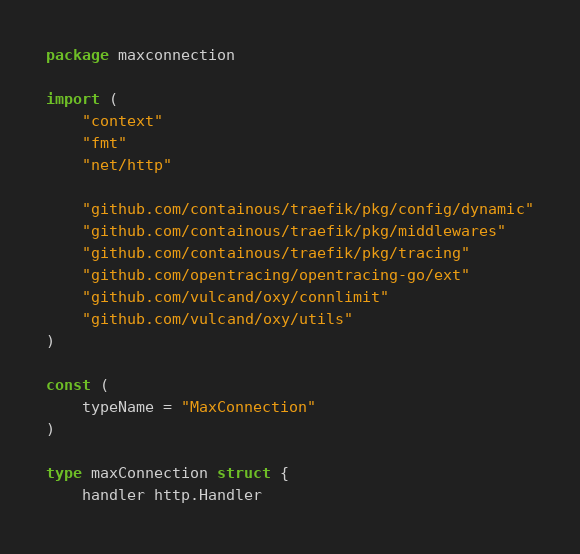<code> <loc_0><loc_0><loc_500><loc_500><_Go_>package maxconnection

import (
	"context"
	"fmt"
	"net/http"

	"github.com/containous/traefik/pkg/config/dynamic"
	"github.com/containous/traefik/pkg/middlewares"
	"github.com/containous/traefik/pkg/tracing"
	"github.com/opentracing/opentracing-go/ext"
	"github.com/vulcand/oxy/connlimit"
	"github.com/vulcand/oxy/utils"
)

const (
	typeName = "MaxConnection"
)

type maxConnection struct {
	handler http.Handler</code> 